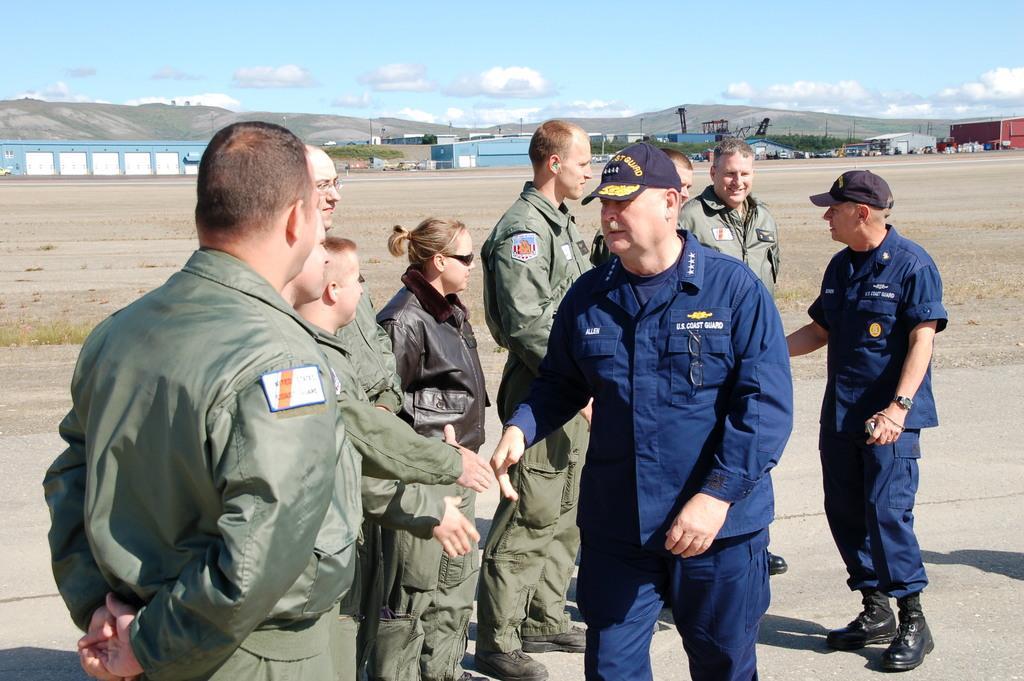Please provide a concise description of this image. In the picture I can see these two persons wearing blue color dresses, caps and shoes are walking on the road and these people wearing dark green color dresses are also standing. In the background, I can see the ground, I can see houses, cranes, trees, hills and the blue color sky with clouds 